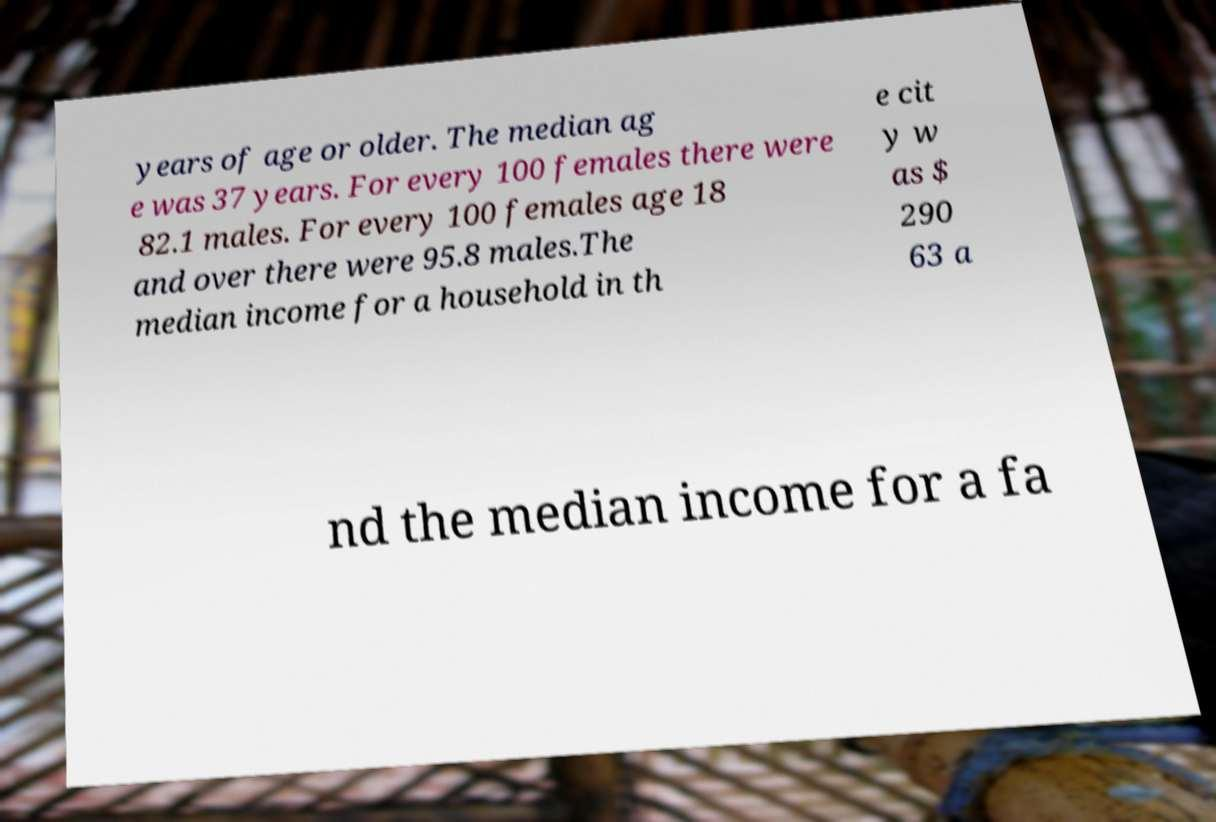For documentation purposes, I need the text within this image transcribed. Could you provide that? years of age or older. The median ag e was 37 years. For every 100 females there were 82.1 males. For every 100 females age 18 and over there were 95.8 males.The median income for a household in th e cit y w as $ 290 63 a nd the median income for a fa 